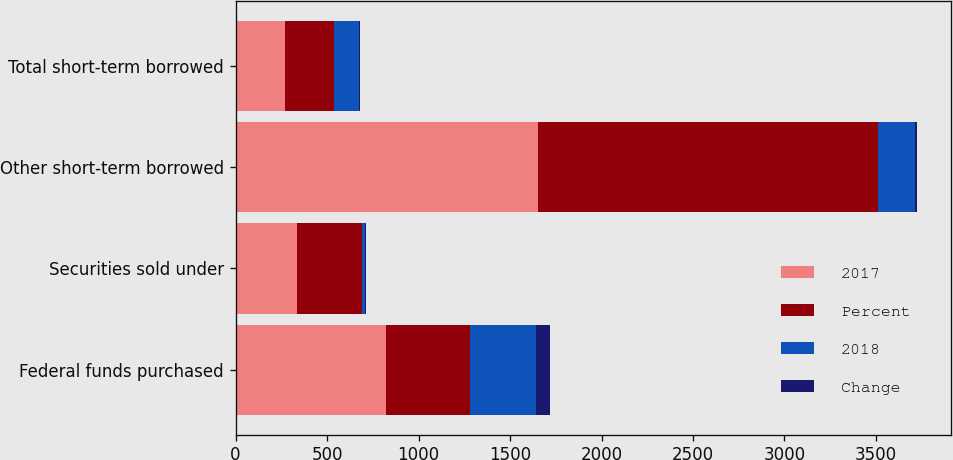Convert chart. <chart><loc_0><loc_0><loc_500><loc_500><stacked_bar_chart><ecel><fcel>Federal funds purchased<fcel>Securities sold under<fcel>Other short-term borrowed<fcel>Total short-term borrowed<nl><fcel>2017<fcel>820<fcel>336<fcel>1653<fcel>269.5<nl><fcel>Percent<fcel>460<fcel>355<fcel>1856<fcel>269.5<nl><fcel>2018<fcel>360<fcel>19<fcel>203<fcel>138<nl><fcel>Change<fcel>78<fcel>5<fcel>11<fcel>5<nl></chart> 